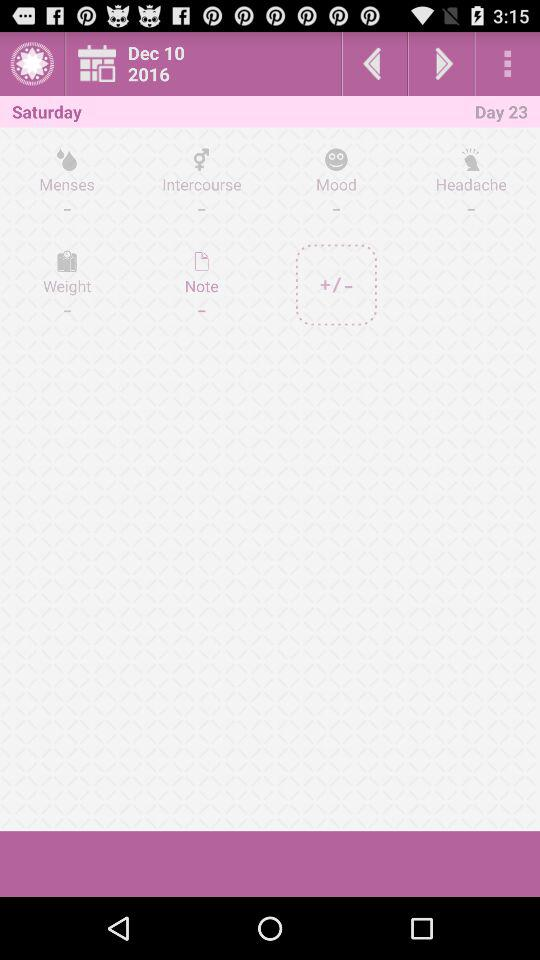What date is shown on the screen? The shown date is December 10, 2016 on the screen. 